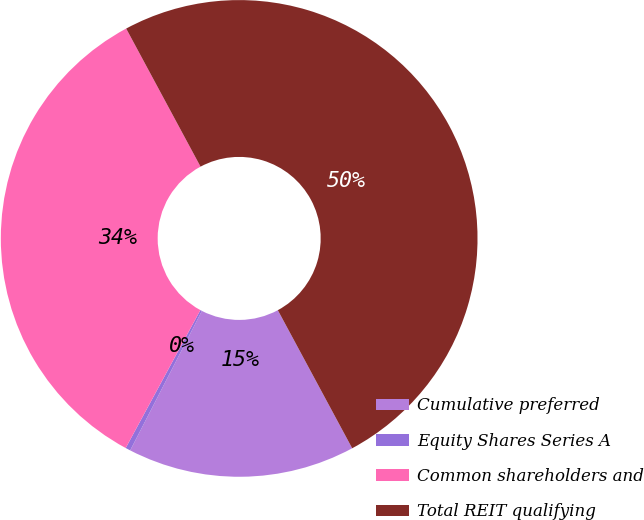<chart> <loc_0><loc_0><loc_500><loc_500><pie_chart><fcel>Cumulative preferred<fcel>Equity Shares Series A<fcel>Common shareholders and<fcel>Total REIT qualifying<nl><fcel>15.42%<fcel>0.34%<fcel>34.24%<fcel>50.0%<nl></chart> 